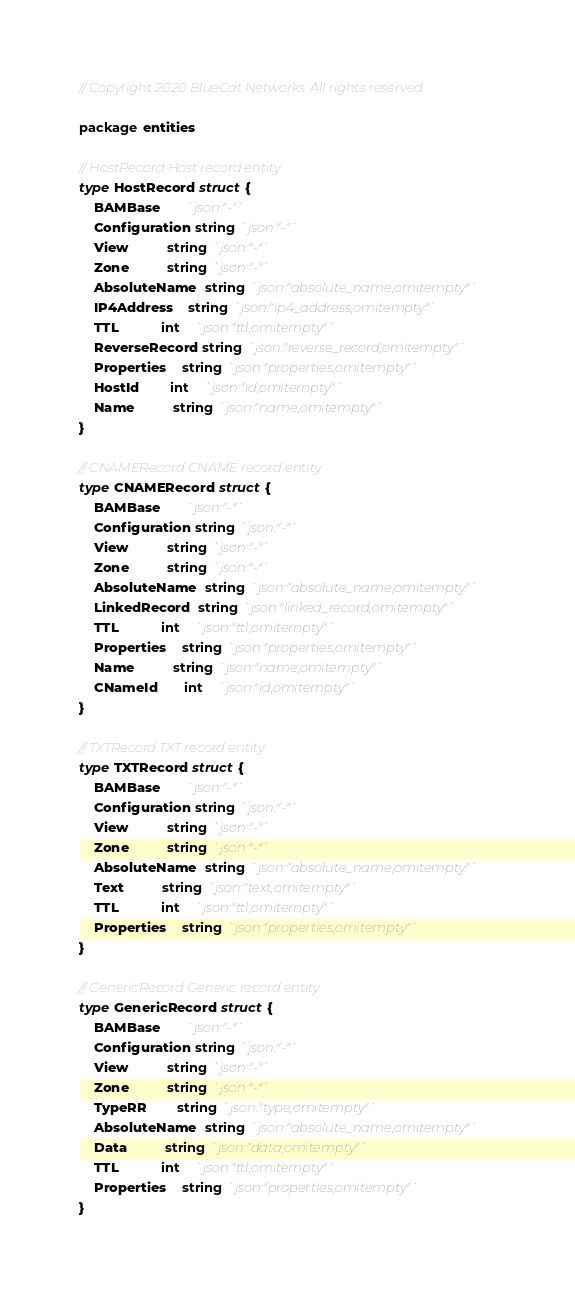Convert code to text. <code><loc_0><loc_0><loc_500><loc_500><_Go_>// Copyright 2020 BlueCat Networks. All rights reserved

package entities

// HostRecord Host record entity
type HostRecord struct {
	BAMBase       `json:"-"`
	Configuration string `json:"-"`
	View          string `json:"-"`
	Zone          string `json:"-"`
	AbsoluteName  string `json:"absolute_name,omitempty"`
	IP4Address    string `json:"ip4_address,omitempty"`
	TTL           int    `json:"ttl,omitempty"`
	ReverseRecord string `json:"reverse_record,omitempty"`
	Properties    string `json:"properties,omitempty"`
	HostId        int    `json:"id,omitempty"`
	Name          string `json:"name,omitempty"`
}

// CNAMERecord CNAME record entity
type CNAMERecord struct {
	BAMBase       `json:"-"`
	Configuration string `json:"-"`
	View          string `json:"-"`
	Zone          string `json:"-"`
	AbsoluteName  string `json:"absolute_name,omitempty"`
	LinkedRecord  string `json:"linked_record,omitempty"`
	TTL           int    `json:"ttl,omitempty"`
	Properties    string `json:"properties,omitempty"`
	Name          string `json:"name,omitempty"`
	CNameId       int    `json:"id,omitempty"`
}

// TXTRecord TXT record entity
type TXTRecord struct {
	BAMBase       `json:"-"`
	Configuration string `json:"-"`
	View          string `json:"-"`
	Zone          string `json:"-"`
	AbsoluteName  string `json:"absolute_name,omitempty"`
	Text          string `json:"text,omitempty"`
	TTL           int    `json:"ttl,omitempty"`
	Properties    string `json:"properties,omitempty"`
}

// GenericRecord Generic record entity
type GenericRecord struct {
	BAMBase       `json:"-"`
	Configuration string `json:"-"`
	View          string `json:"-"`
	Zone          string `json:"-"`
	TypeRR        string `json:"type,omitempty"`
	AbsoluteName  string `json:"absolute_name,omitempty"`
	Data          string `json:"data,omitempty"`
	TTL           int    `json:"ttl,omitempty"`
	Properties    string `json:"properties,omitempty"`
}
</code> 